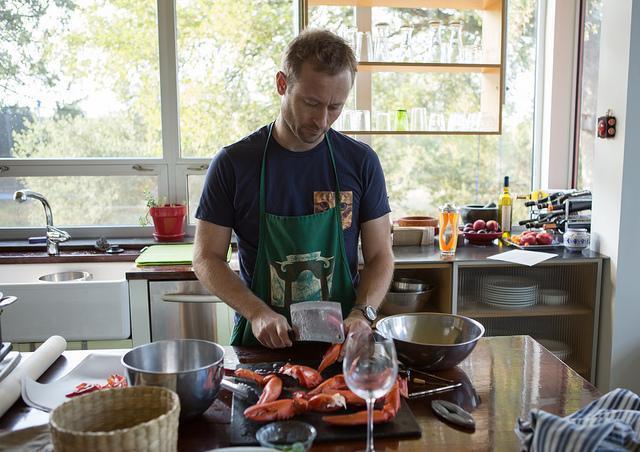How many cups are there?
Give a very brief answer. 1. How many bowls are there?
Give a very brief answer. 3. 